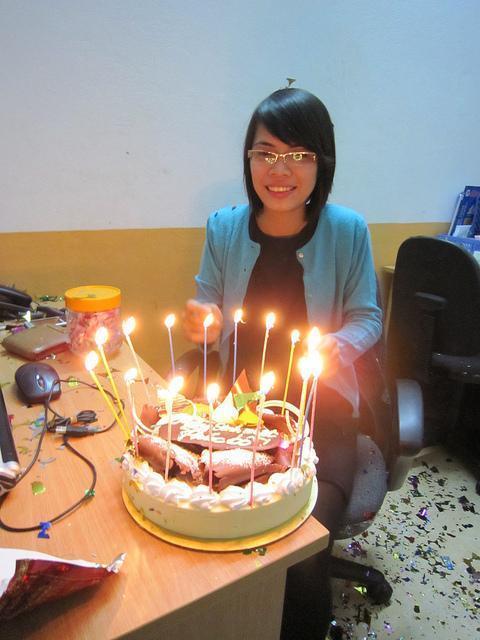How many candles are shown?
Give a very brief answer. 15. How many cakes are in the picture?
Give a very brief answer. 1. How many chairs are visible?
Give a very brief answer. 2. How many keyboards are in the room?
Give a very brief answer. 0. 